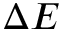Convert formula to latex. <formula><loc_0><loc_0><loc_500><loc_500>\Delta E</formula> 